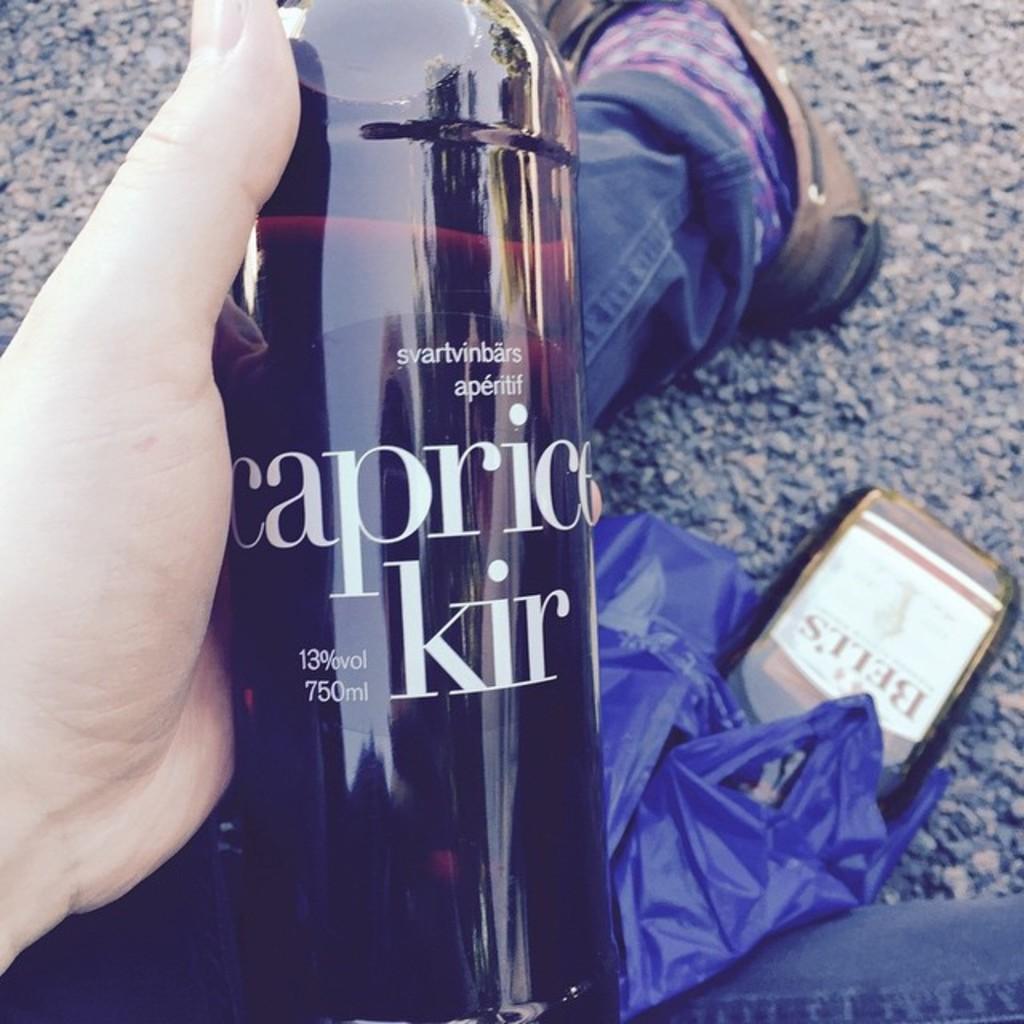Could you give a brief overview of what you see in this image? In the center of the image we can see a person is sitting on the road and wearing jeans, sock, shoe and holding a bottle and also we can see mobile, plastic cover. In the background of the image we can see the road. 